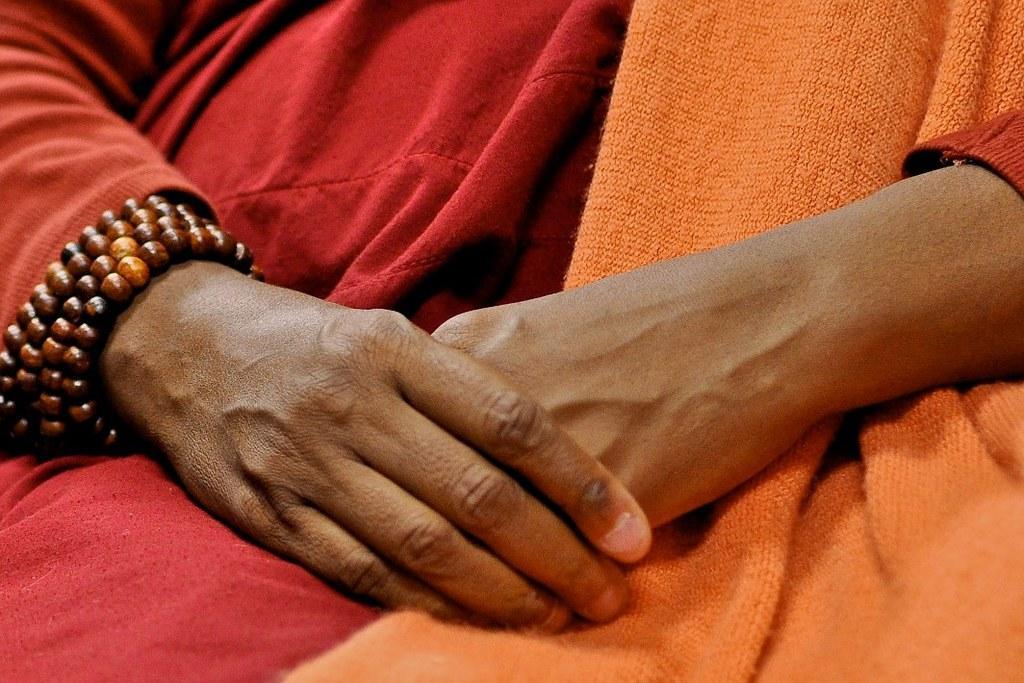In one or two sentences, can you explain what this image depicts? In this image I see the hands of a person and I see the red and orange cloth on the person and I see brown color thing over here 